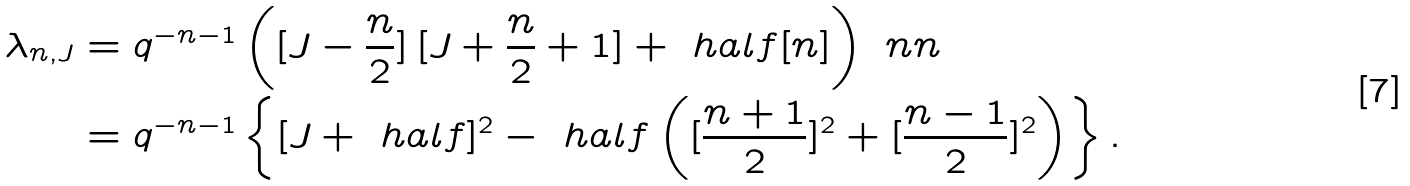Convert formula to latex. <formula><loc_0><loc_0><loc_500><loc_500>\lambda _ { n , J } & = q ^ { - n - 1 } \left ( [ J - \frac { n } { 2 } ] \, [ J + \frac { n } { 2 } + 1 ] + \ h a l f [ n ] \right ) \ n n \\ & = q ^ { - n - 1 } \left \{ [ J + \ h a l f ] ^ { 2 } - \ h a l f \left ( [ \frac { n + 1 } { 2 } ] ^ { 2 } + [ \frac { n - 1 } { 2 } ] ^ { 2 } \right ) \right \} .</formula> 